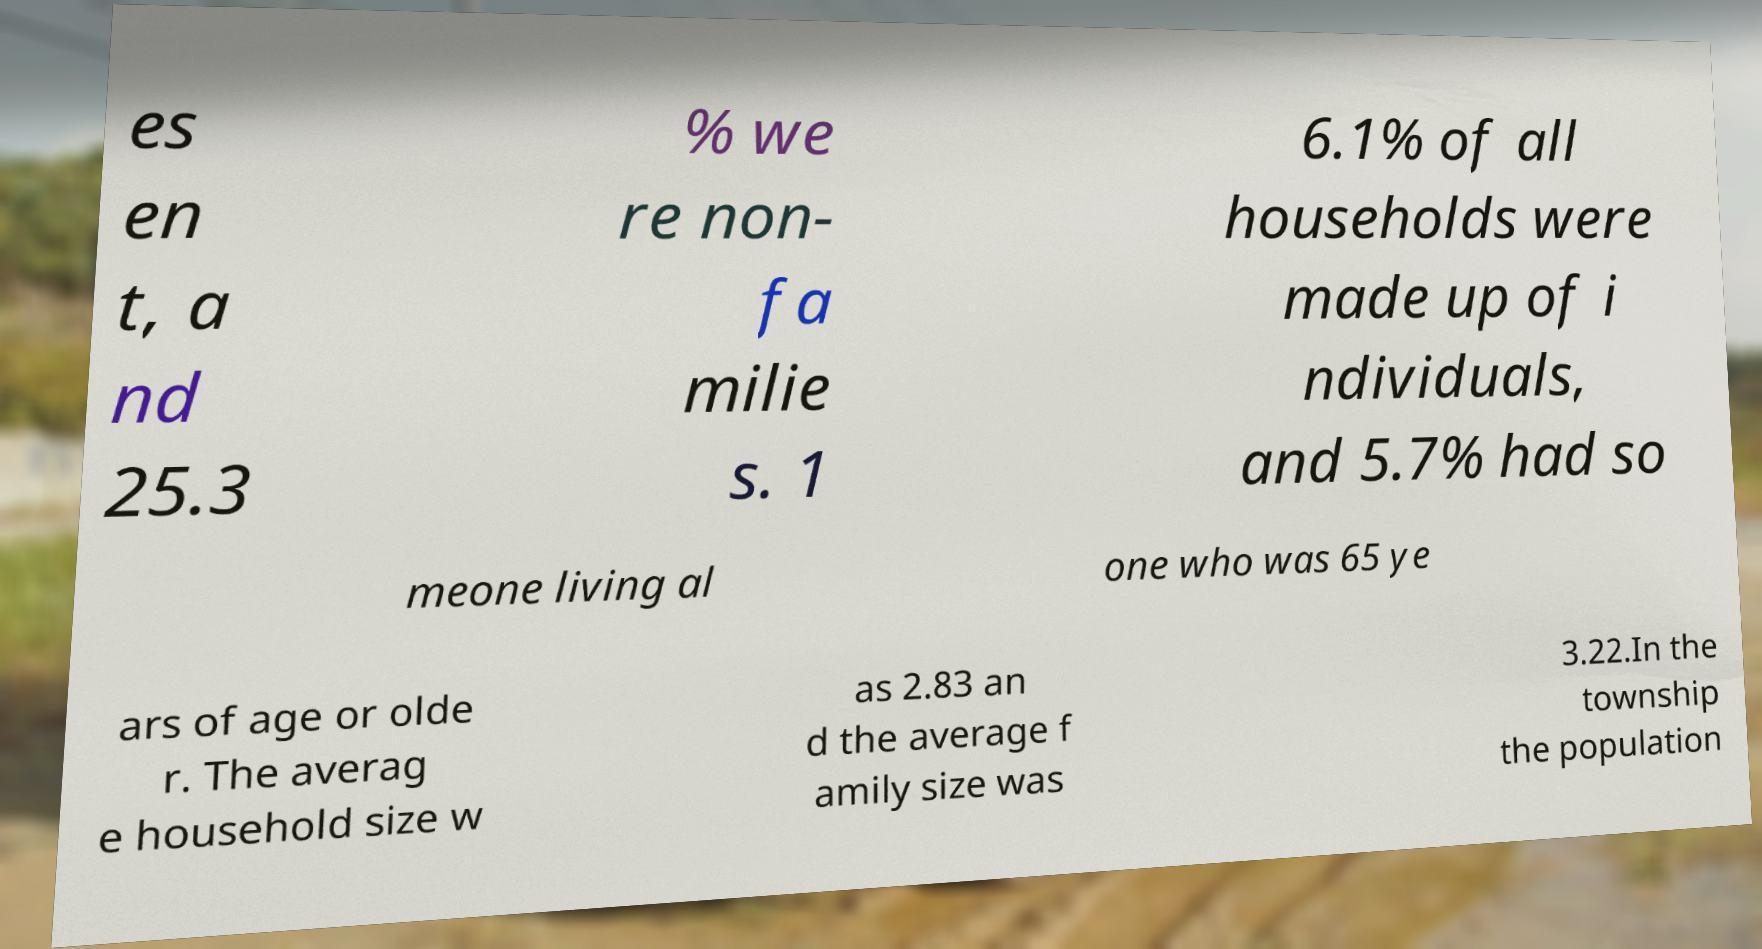What messages or text are displayed in this image? I need them in a readable, typed format. es en t, a nd 25.3 % we re non- fa milie s. 1 6.1% of all households were made up of i ndividuals, and 5.7% had so meone living al one who was 65 ye ars of age or olde r. The averag e household size w as 2.83 an d the average f amily size was 3.22.In the township the population 